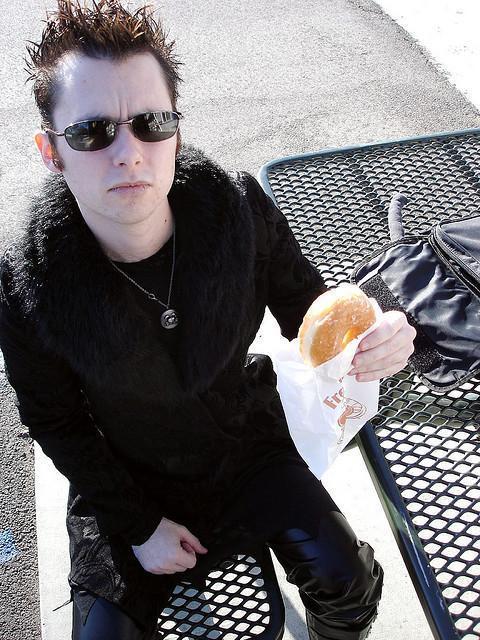Is the caption "The donut is above the dining table." a true representation of the image?
Answer yes or no. Yes. 